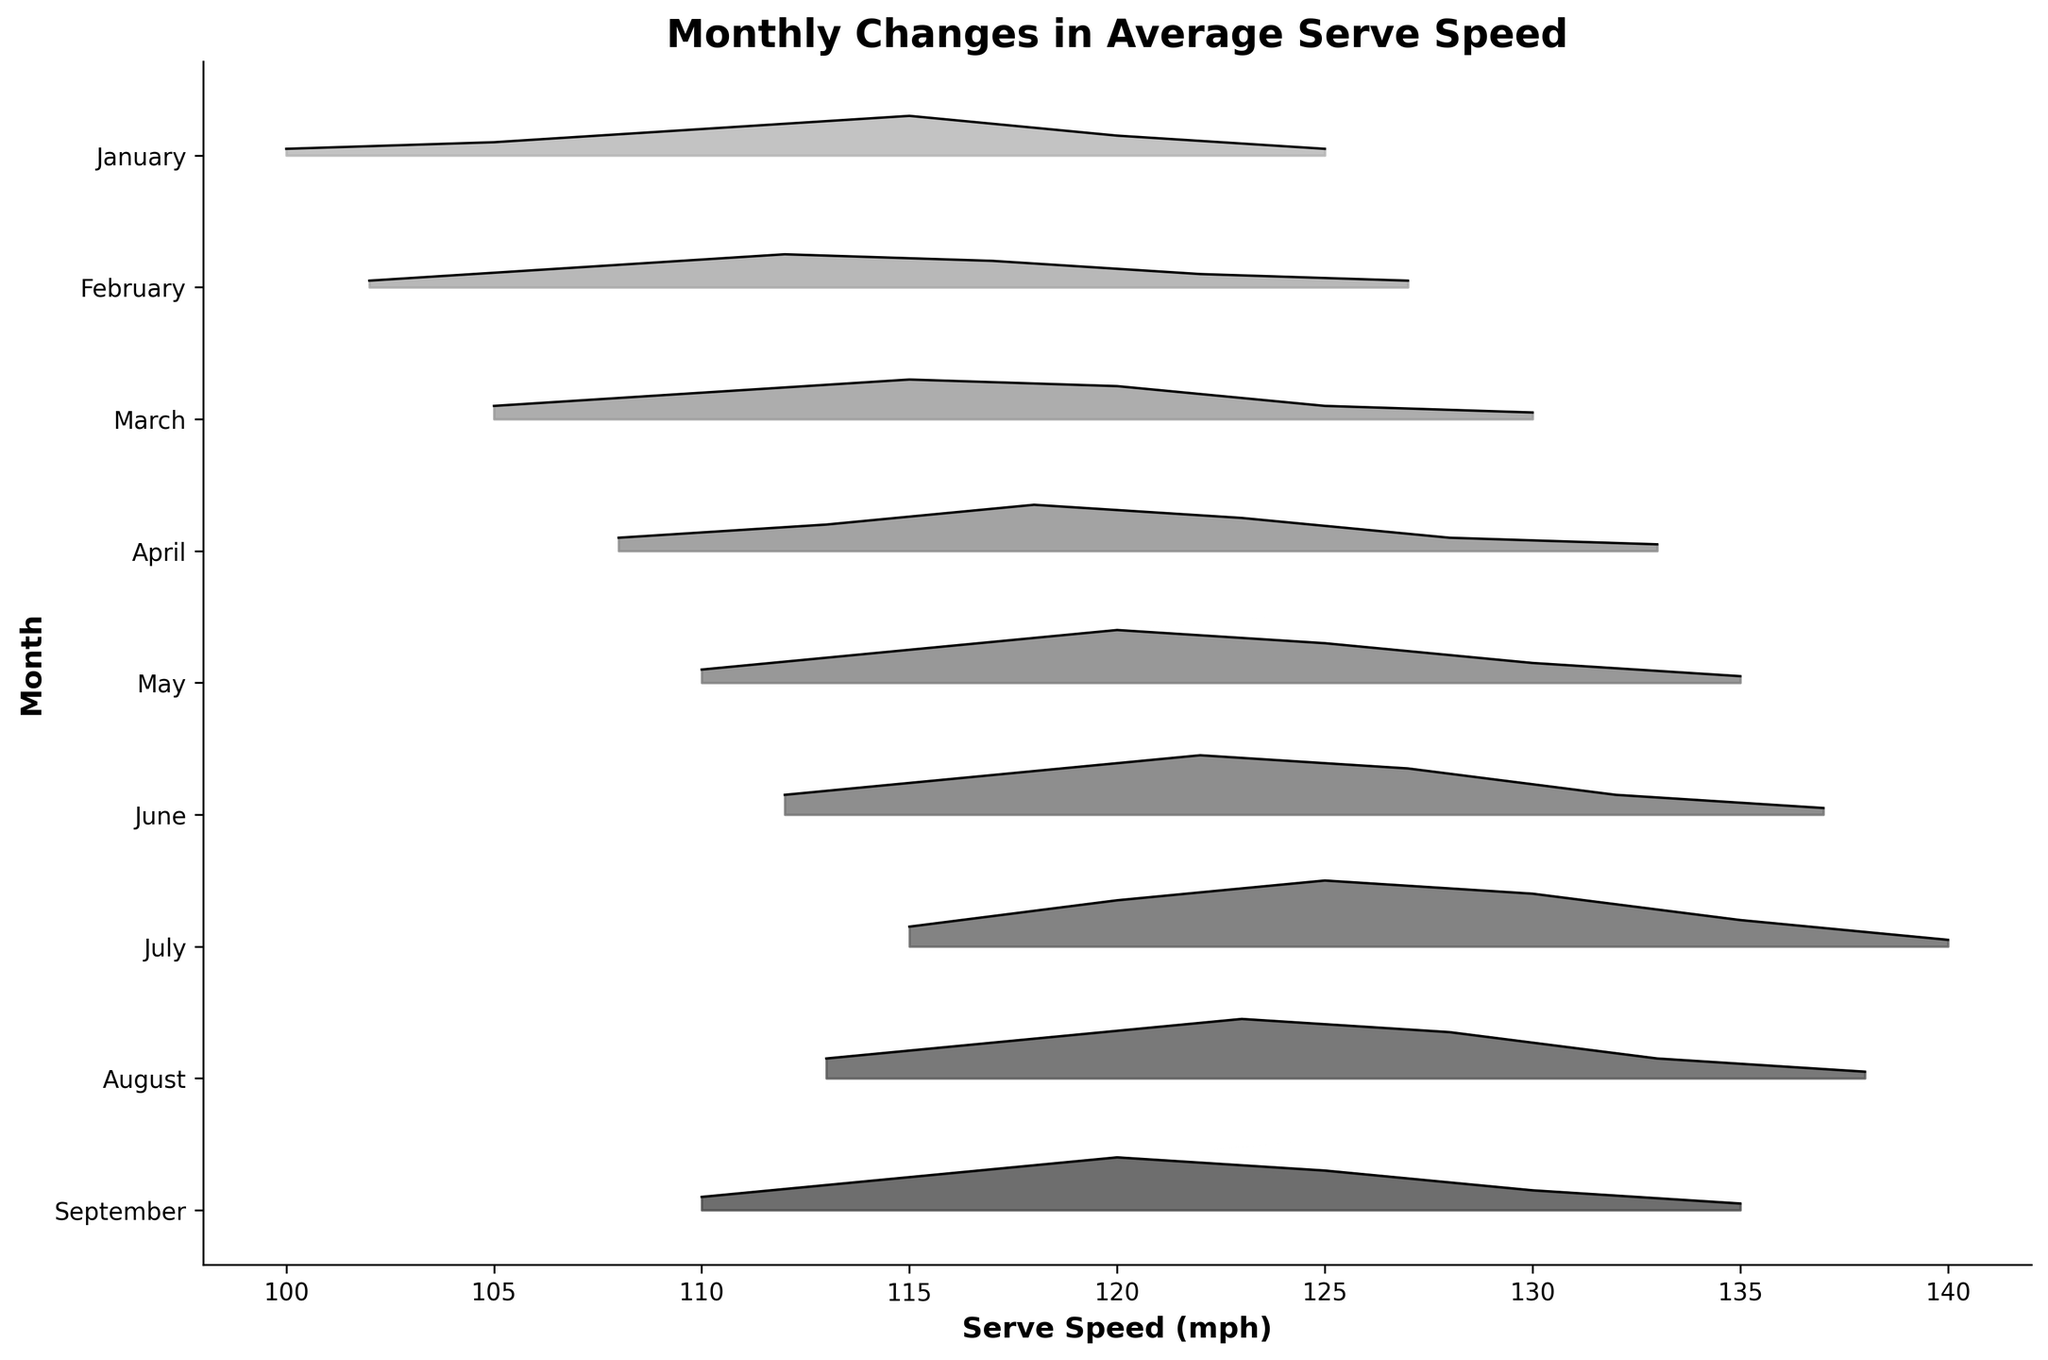What is the title of the plot? The title of the plot is written at the top center of the figure. It summarizes what the plot represents, helping viewers quickly grasp the main theme.
Answer: Monthly Changes in Average Serve Speed How many unique months are displayed in the plot? By counting the distinct labels on the y-axis, you can determine the number of unique months represented in the plot.
Answer: 9 Which month shows the highest serve speed? By inspecting the x-axis for the furthest right peak and noting which month's ridge aligns with it, you can determine which month shows the highest serve speed.
Answer: July Which month has the densest distribution in the middle of the serve speeds? This involves looking at the spread and height of the ridgeline within the middle speed ranges (e.g., around 115-125 mph). The month with the tallest and widest ridgeline there indicates the densest distribution.
Answer: July In which month does the peak serve speed reach 135 mph? Look for the month where the ridgeline reaches 135 mph with the tallest density peak to identify the correct month.
Answer: July What is a noticeable trend in serve speed from January to July? By observing the position and height of the ridgelines from January to July, you can note that the serve speed generally increases each month.
Answer: Serve speed increases Compare the serve speed peaks of February and March. Which month has a higher peak? By comparing the height of the ridgelines for February and March, you can check which has the taller peak.
Answer: March Which month has the steepest increase in serve speed density from 115 mph to 130 mph? This involves examining the slopes of the ridgelines between 115 mph and 130 mph for all months and identifying which month has the most rapid increase.
Answer: July How does the serve speed distribution in August compare to June? Compare the ridgelines for August and June, noting the peaks, spread, and density at different speeds.
Answer: August has a slightly higher peak and is more concentrated in the middle speeds than June What is the overall trend in serve speeds from April to September? By tracking the progression of ridgelines from April to September, you can observe the positions and changes in density peaks, indicating how serve speeds are changing.
Answer: Serve speed generally increases 